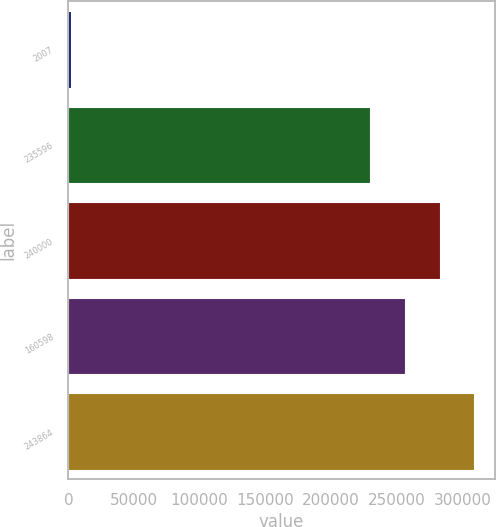Convert chart. <chart><loc_0><loc_0><loc_500><loc_500><bar_chart><fcel>2007<fcel>235596<fcel>240000<fcel>160598<fcel>243864<nl><fcel>2006<fcel>229798<fcel>282709<fcel>256254<fcel>309164<nl></chart> 